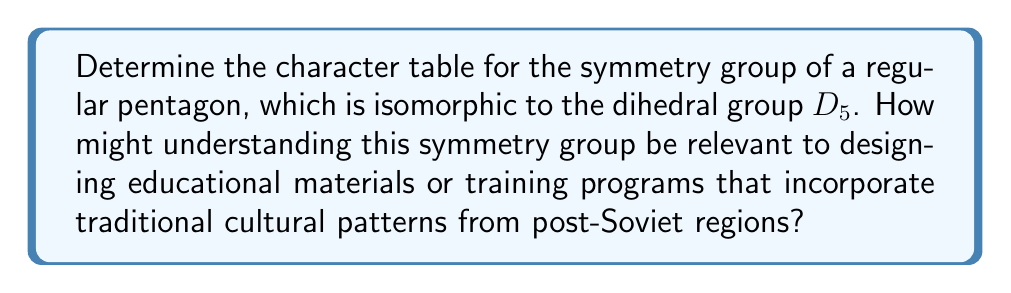Show me your answer to this math problem. Let's approach this step-by-step:

1) First, recall that the dihedral group $D_5$ has order 10 and consists of 5 rotations and 5 reflections.

2) The conjugacy classes of $D_5$ are:
   - $\{e\}$ (identity)
   - $\{r, r^4\}$ (rotations by 72° and 288°)
   - $\{r^2, r^3\}$ (rotations by 144° and 216°)
   - $\{s, sr, sr^2, sr^3, sr^4\}$ (all reflections)

3) $D_5$ has 4 one-dimensional representations and 1 two-dimensional representation:
   - The trivial representation: $\chi_1$
   - The sign representation: $\chi_2$
   - Two more one-dimensional representations: $\chi_3$ and $\chi_4$
   - One two-dimensional representation: $\chi_5$

4) For $\chi_1$, all characters are 1.

5) For $\chi_2$, rotations have character 1, reflections have character -1.

6) For $\chi_3$ and $\chi_4$:
   $$\chi_3(r) = e^{2\pi i/5}, \chi_3(r^2) = e^{4\pi i/5}$$
   $$\chi_4(r) = e^{4\pi i/5}, \chi_4(r^2) = e^{8\pi i/5}$$
   All reflections have character 0 for $\chi_3$ and $\chi_4$.

7) For $\chi_5$, use the formula $\chi_5(g) = 2\cos(\frac{2\pi k}{5})$ for rotations $r^k$, and 0 for reflections.

8) The complete character table:

   $$\begin{array}{c|ccccc}
    D_5 & \{e\} & \{r,r^4\} & \{r^2,r^3\} & \{s,sr,sr^2,sr^3,sr^4\} \\
    \hline
    \chi_1 & 1 & 1 & 1 & 1 \\
    \chi_2 & 1 & 1 & 1 & -1 \\
    \chi_3 & 1 & \phi & \phi^2 & 0 \\
    \chi_4 & 1 & \phi^2 & \phi & 0 \\
    \chi_5 & 2 & 2\cos(\frac{2\pi}{5}) & 2\cos(\frac{4\pi}{5}) & 0
   \end{array}$$

   where $\phi = e^{2\pi i/5}$.

Understanding this symmetry group can be relevant to designing educational materials or training programs in post-Soviet regions as it relates to the geometric patterns often found in traditional art, architecture, and crafts. Many cultural designs incorporate pentagonal symmetry, and understanding the mathematical structure behind these patterns can enhance appreciation and creation of culturally significant works.
Answer: Character table for $D_5$:
$$\begin{array}{c|ccccc}
D_5 & \{e\} & \{r,r^4\} & \{r^2,r^3\} & \{s,sr,sr^2,sr^3,sr^4\} \\
\hline
\chi_1 & 1 & 1 & 1 & 1 \\
\chi_2 & 1 & 1 & 1 & -1 \\
\chi_3 & 1 & \phi & \phi^2 & 0 \\
\chi_4 & 1 & \phi^2 & \phi & 0 \\
\chi_5 & 2 & 2\cos(\frac{2\pi}{5}) & 2\cos(\frac{4\pi}{5}) & 0
\end{array}$$
where $\phi = e^{2\pi i/5}$ 